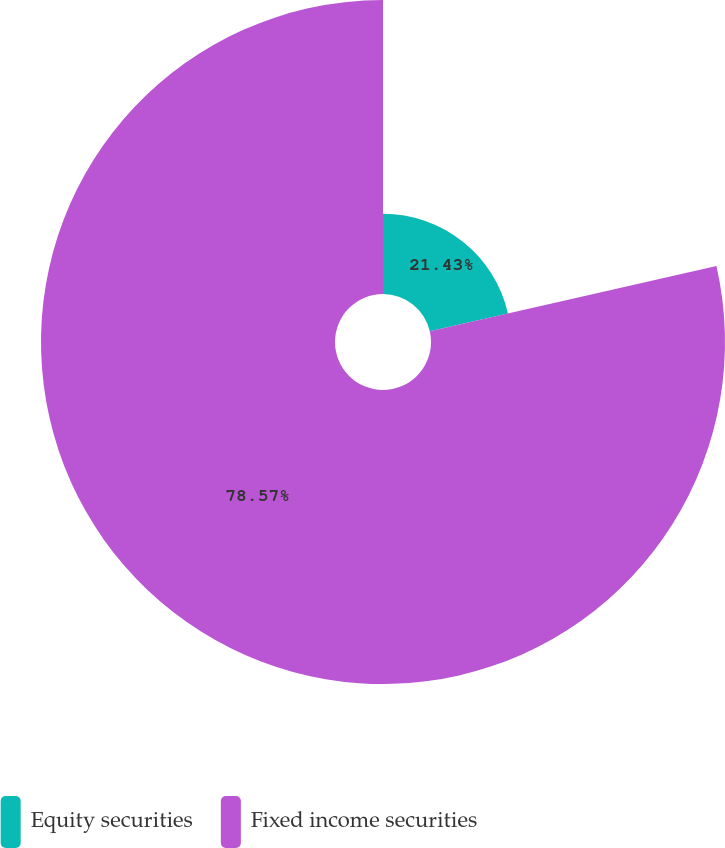Convert chart. <chart><loc_0><loc_0><loc_500><loc_500><pie_chart><fcel>Equity securities<fcel>Fixed income securities<nl><fcel>21.43%<fcel>78.57%<nl></chart> 